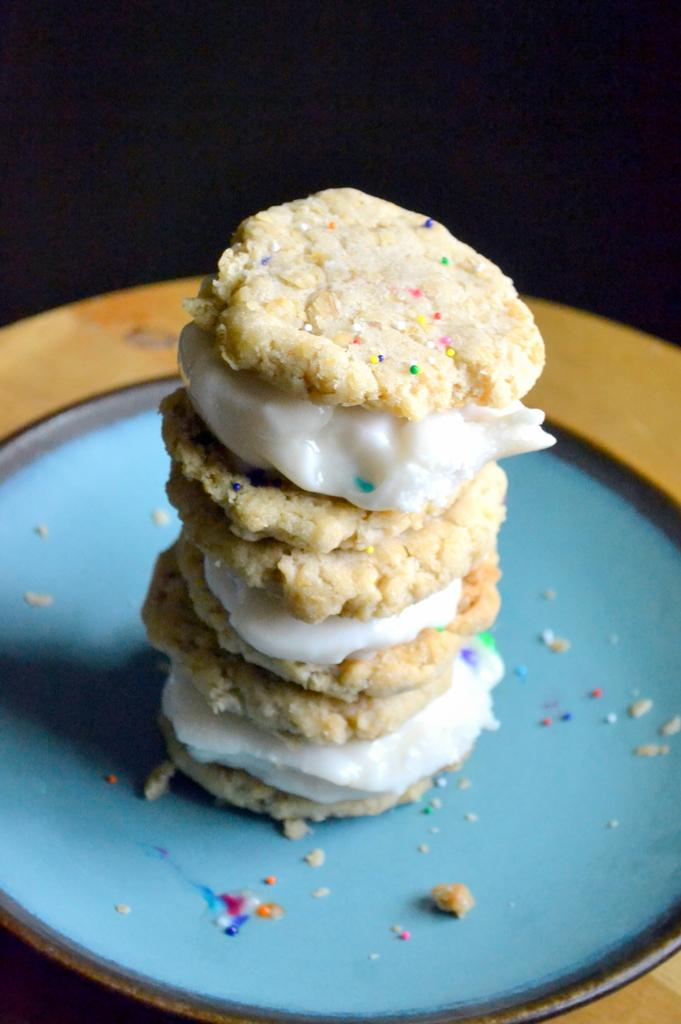What is on the plate that is visible in the image? There is food on a plate in the image. What is the plate resting on? The plate is on a wooden surface. How would you describe the lighting in the image? The background of the image is dark. What type of sack is being used to spy on the food in the image? There is no sack or spying activity present in the image; it simply shows food on a plate. 